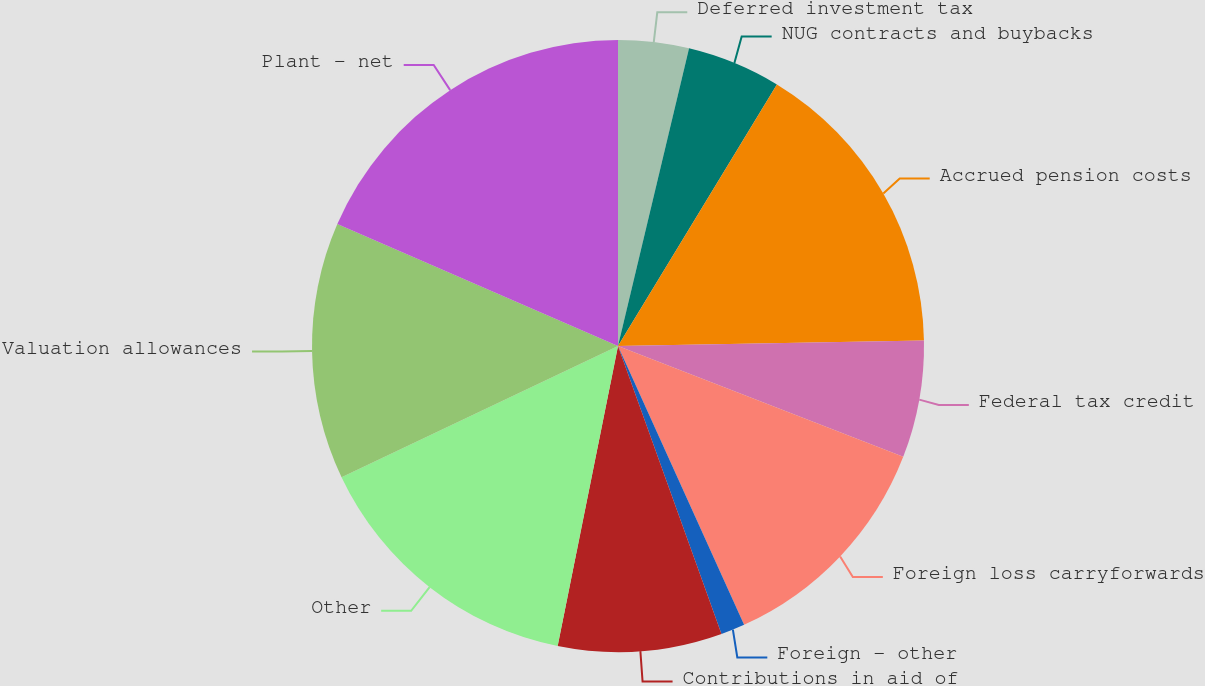<chart> <loc_0><loc_0><loc_500><loc_500><pie_chart><fcel>Deferred investment tax<fcel>NUG contracts and buybacks<fcel>Accrued pension costs<fcel>Federal tax credit<fcel>Foreign loss carryforwards<fcel>Foreign - other<fcel>Contributions in aid of<fcel>Other<fcel>Valuation allowances<fcel>Plant - net<nl><fcel>3.73%<fcel>4.96%<fcel>16.02%<fcel>6.19%<fcel>12.34%<fcel>1.27%<fcel>8.65%<fcel>14.79%<fcel>13.57%<fcel>18.48%<nl></chart> 